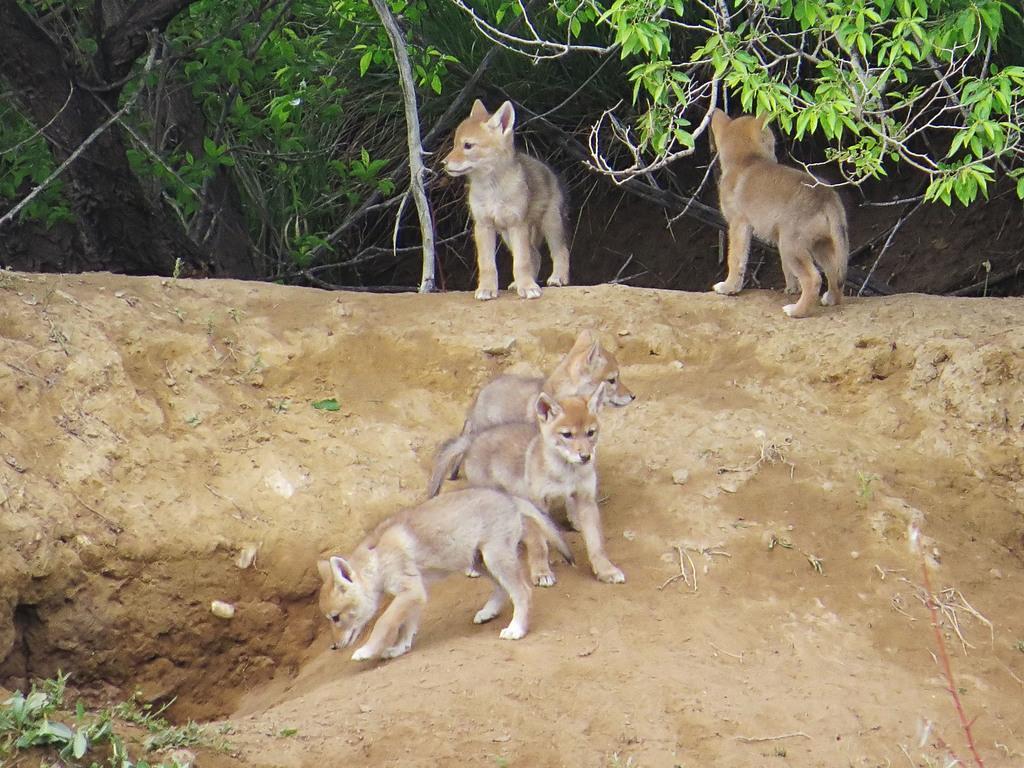Please provide a concise description of this image. In this image we can see some animals on the ground. We can also see some plants. 